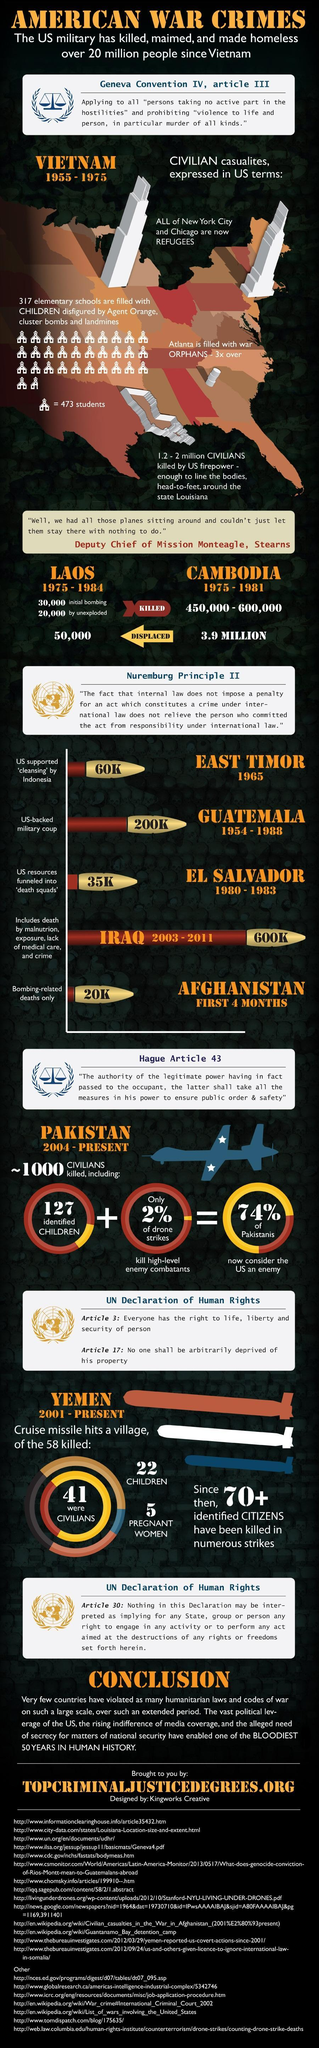How many people fled from Cambodia during 1975-1981?
Answer the question with a short phrase. 3.9 MILLION How many people were killed in Cambodia during 1975-1981? 450,000 - 600,000 